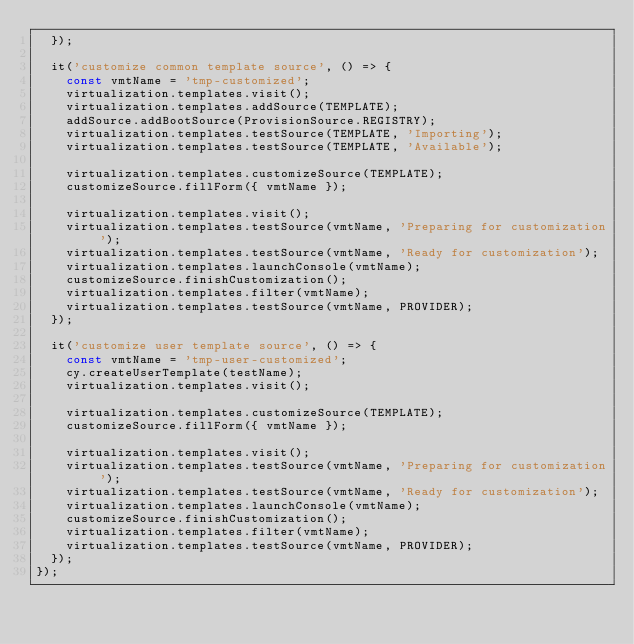<code> <loc_0><loc_0><loc_500><loc_500><_TypeScript_>  });

  it('customize common template source', () => {
    const vmtName = 'tmp-customized';
    virtualization.templates.visit();
    virtualization.templates.addSource(TEMPLATE);
    addSource.addBootSource(ProvisionSource.REGISTRY);
    virtualization.templates.testSource(TEMPLATE, 'Importing');
    virtualization.templates.testSource(TEMPLATE, 'Available');

    virtualization.templates.customizeSource(TEMPLATE);
    customizeSource.fillForm({ vmtName });

    virtualization.templates.visit();
    virtualization.templates.testSource(vmtName, 'Preparing for customization');
    virtualization.templates.testSource(vmtName, 'Ready for customization');
    virtualization.templates.launchConsole(vmtName);
    customizeSource.finishCustomization();
    virtualization.templates.filter(vmtName);
    virtualization.templates.testSource(vmtName, PROVIDER);
  });

  it('customize user template source', () => {
    const vmtName = 'tmp-user-customized';
    cy.createUserTemplate(testName);
    virtualization.templates.visit();

    virtualization.templates.customizeSource(TEMPLATE);
    customizeSource.fillForm({ vmtName });

    virtualization.templates.visit();
    virtualization.templates.testSource(vmtName, 'Preparing for customization');
    virtualization.templates.testSource(vmtName, 'Ready for customization');
    virtualization.templates.launchConsole(vmtName);
    customizeSource.finishCustomization();
    virtualization.templates.filter(vmtName);
    virtualization.templates.testSource(vmtName, PROVIDER);
  });
});
</code> 